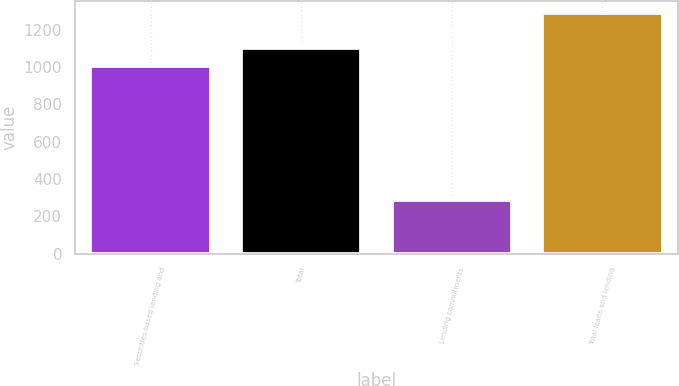Convert chart to OTSL. <chart><loc_0><loc_0><loc_500><loc_500><bar_chart><fcel>Securities-based lending and<fcel>Total<fcel>Lending commitments<fcel>Total loans and lending<nl><fcel>1004<fcel>1104.4<fcel>286<fcel>1290<nl></chart> 